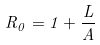<formula> <loc_0><loc_0><loc_500><loc_500>R _ { 0 } = 1 + \frac { L } { A }</formula> 